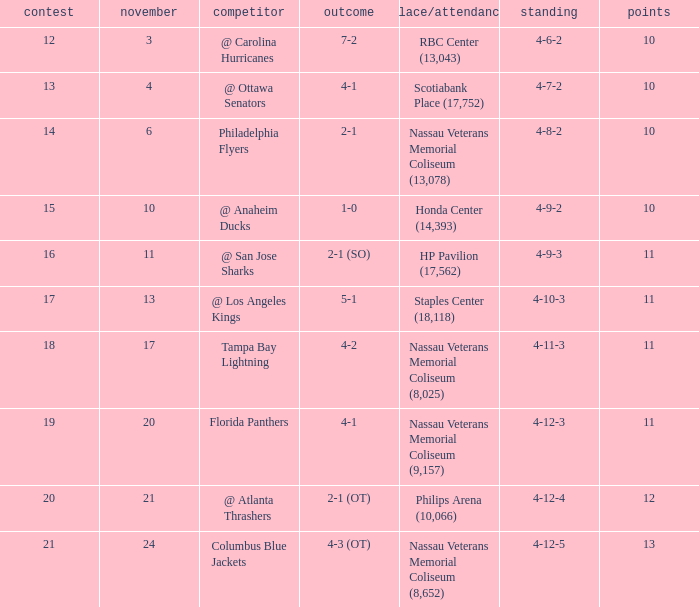What is the highest entry in November for the game 20? 21.0. Help me parse the entirety of this table. {'header': ['contest', 'november', 'competitor', 'outcome', 'place/attendance', 'standing', 'points'], 'rows': [['12', '3', '@ Carolina Hurricanes', '7-2', 'RBC Center (13,043)', '4-6-2', '10'], ['13', '4', '@ Ottawa Senators', '4-1', 'Scotiabank Place (17,752)', '4-7-2', '10'], ['14', '6', 'Philadelphia Flyers', '2-1', 'Nassau Veterans Memorial Coliseum (13,078)', '4-8-2', '10'], ['15', '10', '@ Anaheim Ducks', '1-0', 'Honda Center (14,393)', '4-9-2', '10'], ['16', '11', '@ San Jose Sharks', '2-1 (SO)', 'HP Pavilion (17,562)', '4-9-3', '11'], ['17', '13', '@ Los Angeles Kings', '5-1', 'Staples Center (18,118)', '4-10-3', '11'], ['18', '17', 'Tampa Bay Lightning', '4-2', 'Nassau Veterans Memorial Coliseum (8,025)', '4-11-3', '11'], ['19', '20', 'Florida Panthers', '4-1', 'Nassau Veterans Memorial Coliseum (9,157)', '4-12-3', '11'], ['20', '21', '@ Atlanta Thrashers', '2-1 (OT)', 'Philips Arena (10,066)', '4-12-4', '12'], ['21', '24', 'Columbus Blue Jackets', '4-3 (OT)', 'Nassau Veterans Memorial Coliseum (8,652)', '4-12-5', '13']]} 